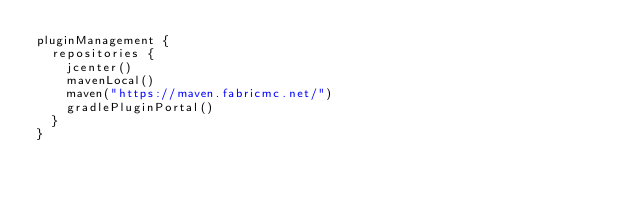Convert code to text. <code><loc_0><loc_0><loc_500><loc_500><_Kotlin_>pluginManagement {
  repositories {
    jcenter()
    mavenLocal()
    maven("https://maven.fabricmc.net/")
    gradlePluginPortal()
  }
}
</code> 